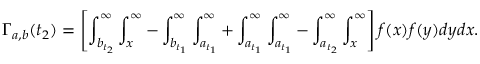Convert formula to latex. <formula><loc_0><loc_0><loc_500><loc_500>\Gamma _ { a , b } ( t _ { 2 } ) = \left [ \int _ { b _ { t _ { 2 } } } ^ { \infty } \int _ { x } ^ { \infty } - \int _ { b _ { t _ { 1 } } } ^ { \infty } \int _ { a _ { t _ { 1 } } } ^ { \infty } + \int _ { a _ { t _ { 1 } } } ^ { \infty } \int _ { a _ { t _ { 1 } } } ^ { \infty } - \int _ { a _ { t _ { 2 } } } ^ { \infty } \int _ { x } ^ { \infty } \right ] f ( x ) f ( y ) d y d x .</formula> 